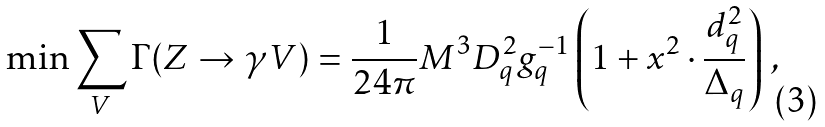<formula> <loc_0><loc_0><loc_500><loc_500>\min \sum _ { V } \Gamma ( Z \rightarrow \gamma V ) = \frac { 1 } { 2 4 \pi } M ^ { 3 } D _ { q } ^ { 2 } g _ { q } ^ { - 1 } \left ( 1 + x ^ { 2 } \cdot \frac { d _ { q } ^ { 2 } } { \Delta _ { q } } \right ) \, ,</formula> 